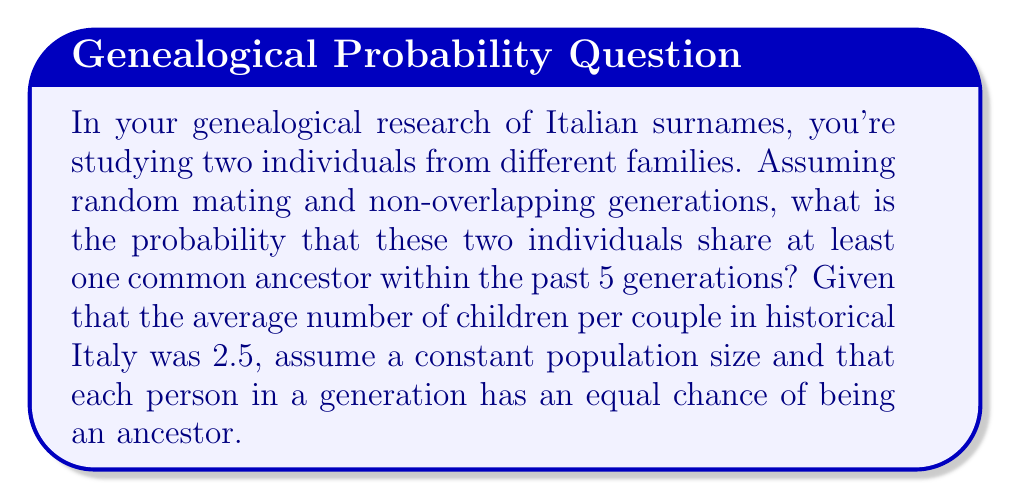Show me your answer to this math problem. Let's approach this step-by-step:

1) First, we need to calculate the number of ancestors each person has in 5 generations:
   $$ \text{Number of ancestors} = 2 + 2^2 + 2^3 + 2^4 + 2^5 = 62 $$

2) The probability of not sharing an ancestor is the probability that all 62 ancestors of one person are different from all 62 ancestors of the other person.

3) In a constant population, the probability of any two individuals not sharing a specific ancestor is:
   $$ P(\text{not sharing}) = 1 - \frac{1}{N} $$
   where $N$ is the population size.

4) For all 62 ancestors, the probability of not sharing any is:
   $$ P(\text{not sharing any}) = \left(1 - \frac{1}{N}\right)^{62} $$

5) Therefore, the probability of sharing at least one ancestor is:
   $$ P(\text{sharing}) = 1 - \left(1 - \frac{1}{N}\right)^{62} $$

6) To find $N$, we can use the fact that the population is constant and each couple has 2.5 children on average:
   $$ N = 2.5^5 = 97.65625 $$

7) Substituting this into our equation:
   $$ P(\text{sharing}) = 1 - \left(1 - \frac{1}{97.65625}\right)^{62} $$

8) Calculating this:
   $$ P(\text{sharing}) = 1 - (0.9897663)^{62} = 0.4748 $$

Therefore, the probability of the two individuals sharing at least one common ancestor within 5 generations is approximately 0.4748 or 47.48%.
Answer: 0.4748 